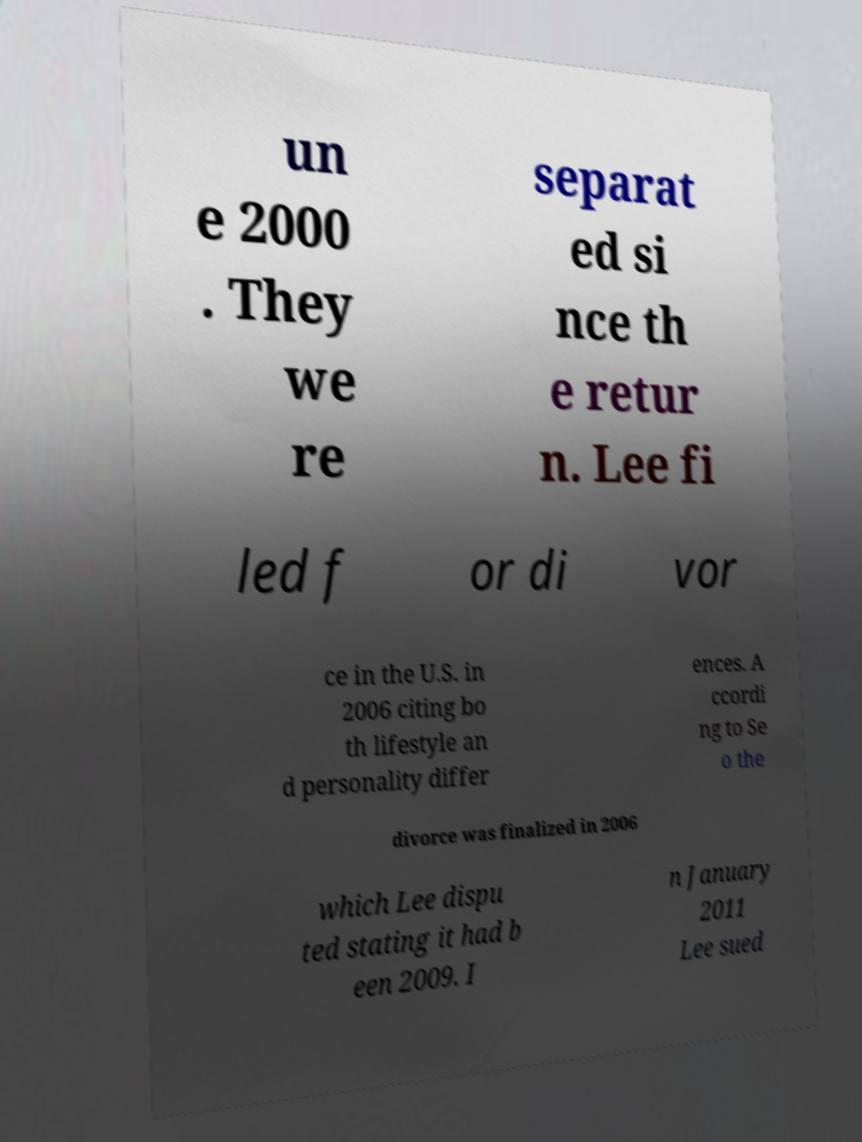What messages or text are displayed in this image? I need them in a readable, typed format. un e 2000 . They we re separat ed si nce th e retur n. Lee fi led f or di vor ce in the U.S. in 2006 citing bo th lifestyle an d personality differ ences. A ccordi ng to Se o the divorce was finalized in 2006 which Lee dispu ted stating it had b een 2009. I n January 2011 Lee sued 